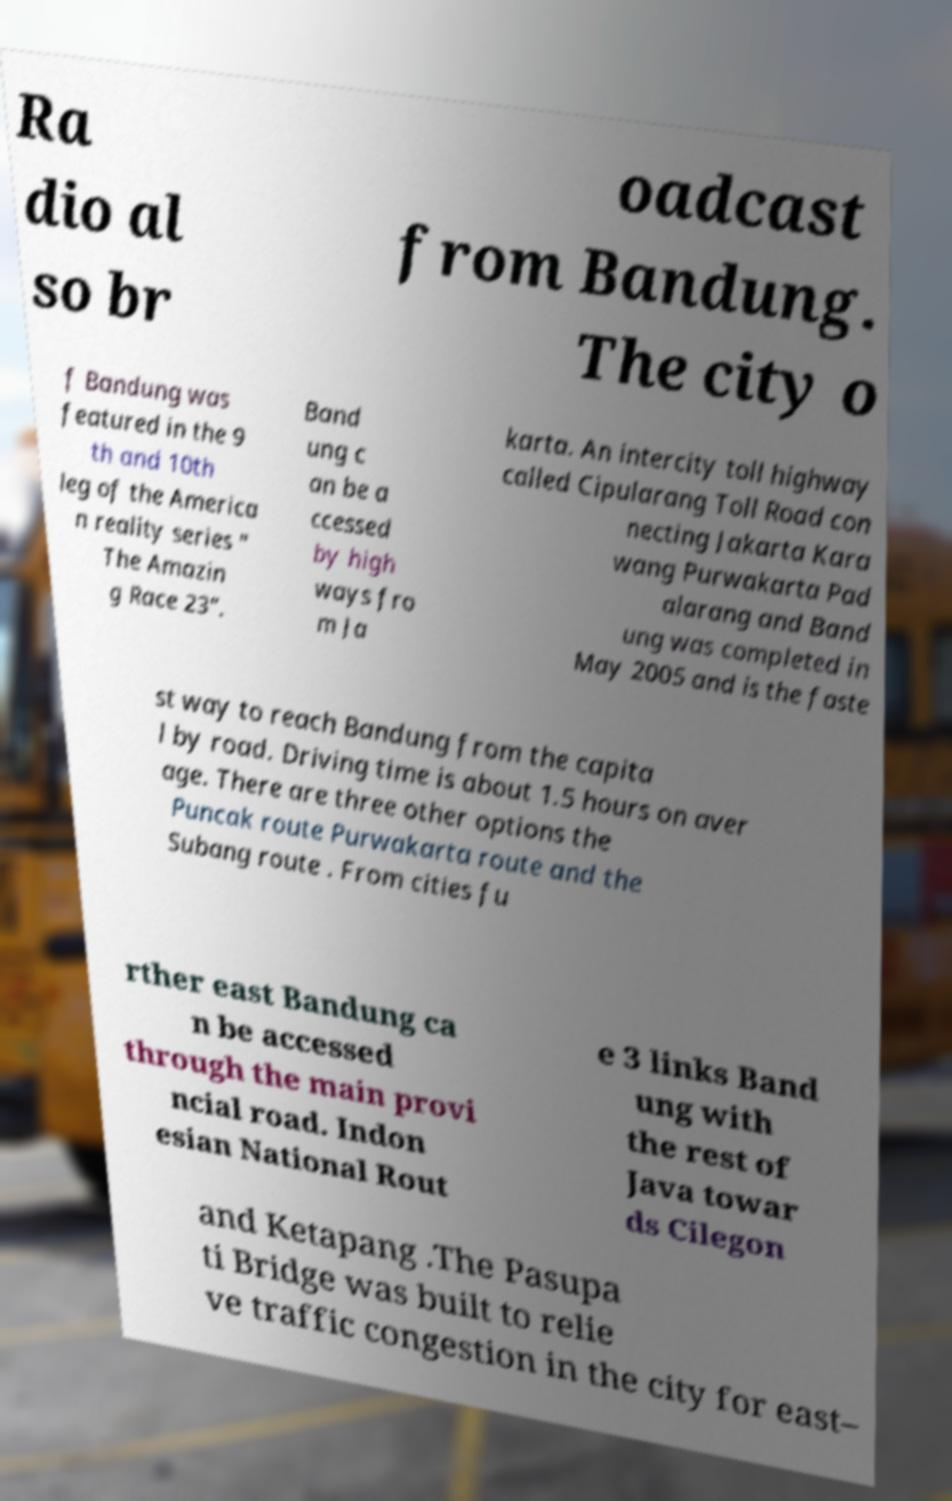Please read and relay the text visible in this image. What does it say? Ra dio al so br oadcast from Bandung. The city o f Bandung was featured in the 9 th and 10th leg of the America n reality series " The Amazin g Race 23". Band ung c an be a ccessed by high ways fro m Ja karta. An intercity toll highway called Cipularang Toll Road con necting Jakarta Kara wang Purwakarta Pad alarang and Band ung was completed in May 2005 and is the faste st way to reach Bandung from the capita l by road. Driving time is about 1.5 hours on aver age. There are three other options the Puncak route Purwakarta route and the Subang route . From cities fu rther east Bandung ca n be accessed through the main provi ncial road. Indon esian National Rout e 3 links Band ung with the rest of Java towar ds Cilegon and Ketapang .The Pasupa ti Bridge was built to relie ve traffic congestion in the city for east– 